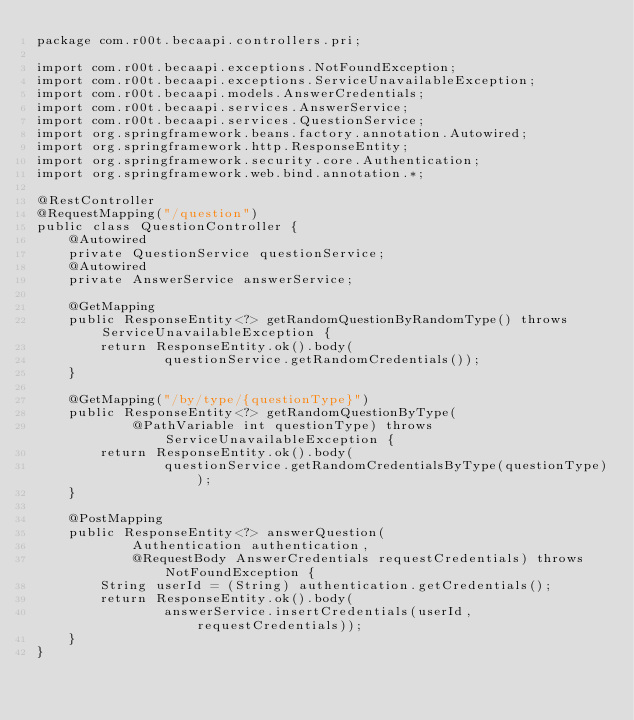<code> <loc_0><loc_0><loc_500><loc_500><_Java_>package com.r00t.becaapi.controllers.pri;

import com.r00t.becaapi.exceptions.NotFoundException;
import com.r00t.becaapi.exceptions.ServiceUnavailableException;
import com.r00t.becaapi.models.AnswerCredentials;
import com.r00t.becaapi.services.AnswerService;
import com.r00t.becaapi.services.QuestionService;
import org.springframework.beans.factory.annotation.Autowired;
import org.springframework.http.ResponseEntity;
import org.springframework.security.core.Authentication;
import org.springframework.web.bind.annotation.*;

@RestController
@RequestMapping("/question")
public class QuestionController {
    @Autowired
    private QuestionService questionService;
    @Autowired
    private AnswerService answerService;

    @GetMapping
    public ResponseEntity<?> getRandomQuestionByRandomType() throws ServiceUnavailableException {
        return ResponseEntity.ok().body(
                questionService.getRandomCredentials());
    }

    @GetMapping("/by/type/{questionType}")
    public ResponseEntity<?> getRandomQuestionByType(
            @PathVariable int questionType) throws ServiceUnavailableException {
        return ResponseEntity.ok().body(
                questionService.getRandomCredentialsByType(questionType));
    }

    @PostMapping
    public ResponseEntity<?> answerQuestion(
            Authentication authentication,
            @RequestBody AnswerCredentials requestCredentials) throws NotFoundException {
        String userId = (String) authentication.getCredentials();
        return ResponseEntity.ok().body(
                answerService.insertCredentials(userId, requestCredentials));
    }
}
</code> 